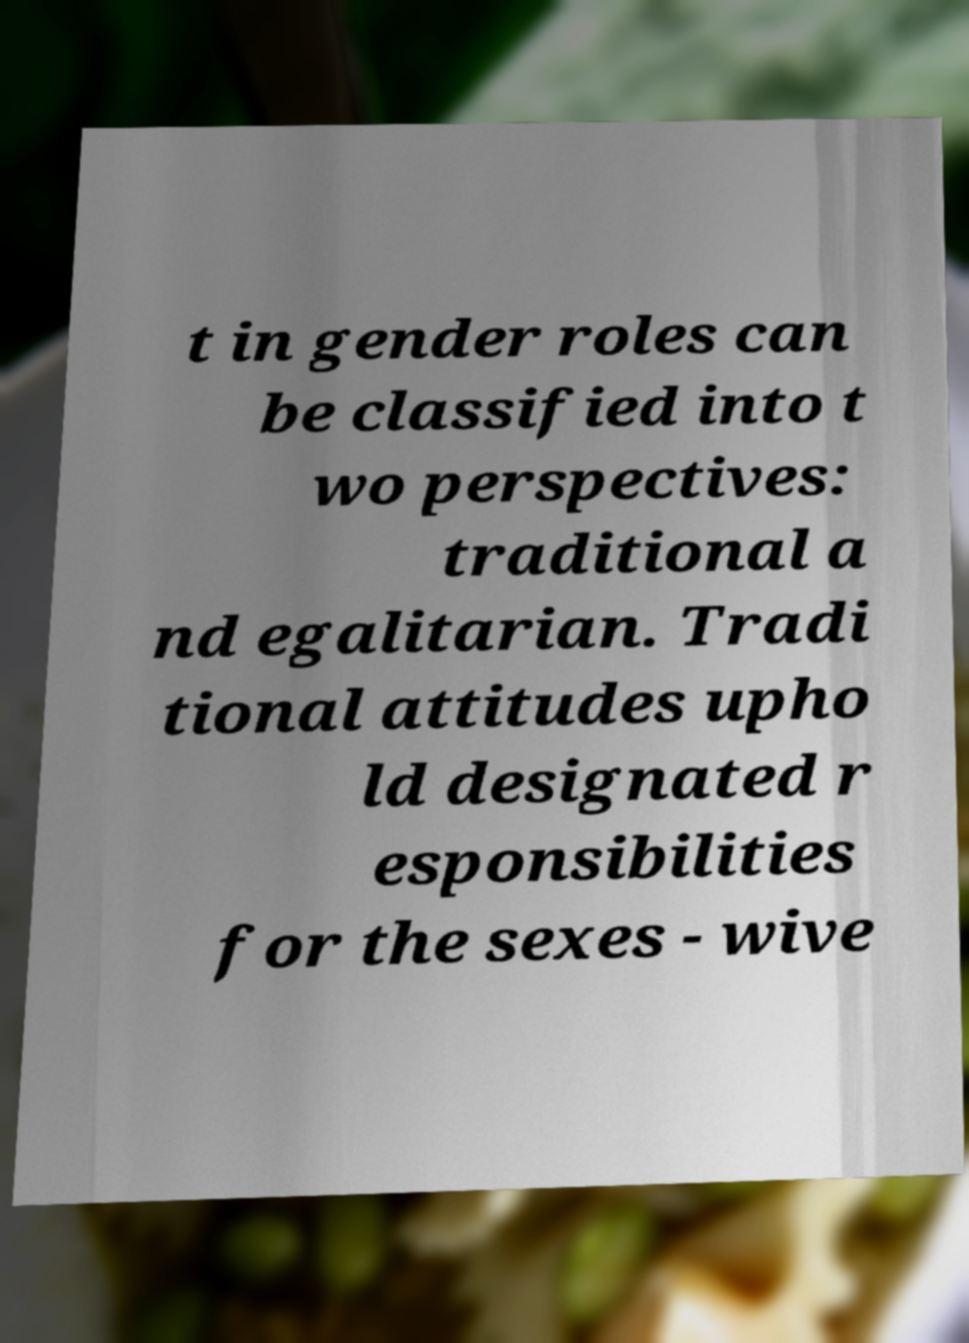Could you extract and type out the text from this image? t in gender roles can be classified into t wo perspectives: traditional a nd egalitarian. Tradi tional attitudes upho ld designated r esponsibilities for the sexes - wive 